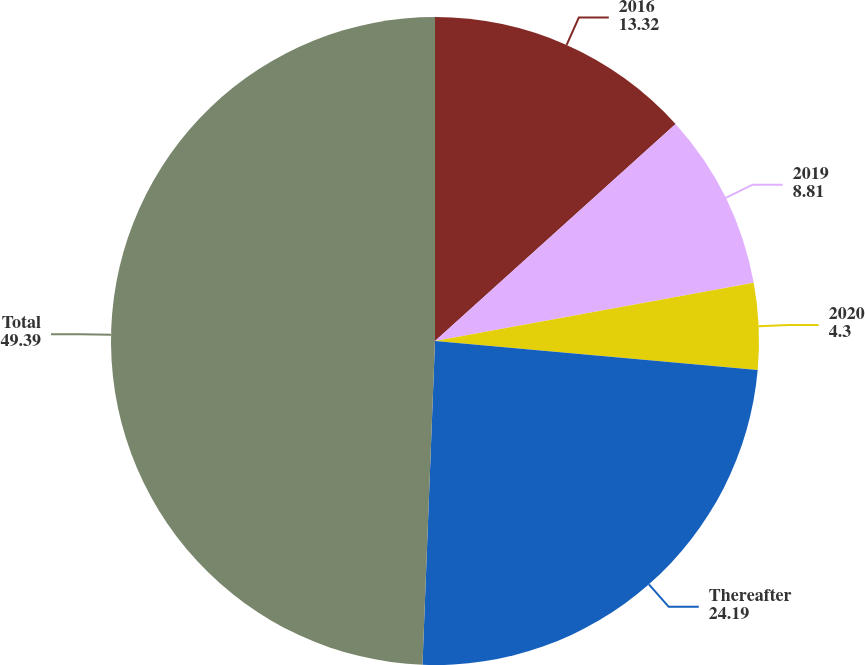<chart> <loc_0><loc_0><loc_500><loc_500><pie_chart><fcel>2016<fcel>2019<fcel>2020<fcel>Thereafter<fcel>Total<nl><fcel>13.32%<fcel>8.81%<fcel>4.3%<fcel>24.19%<fcel>49.39%<nl></chart> 